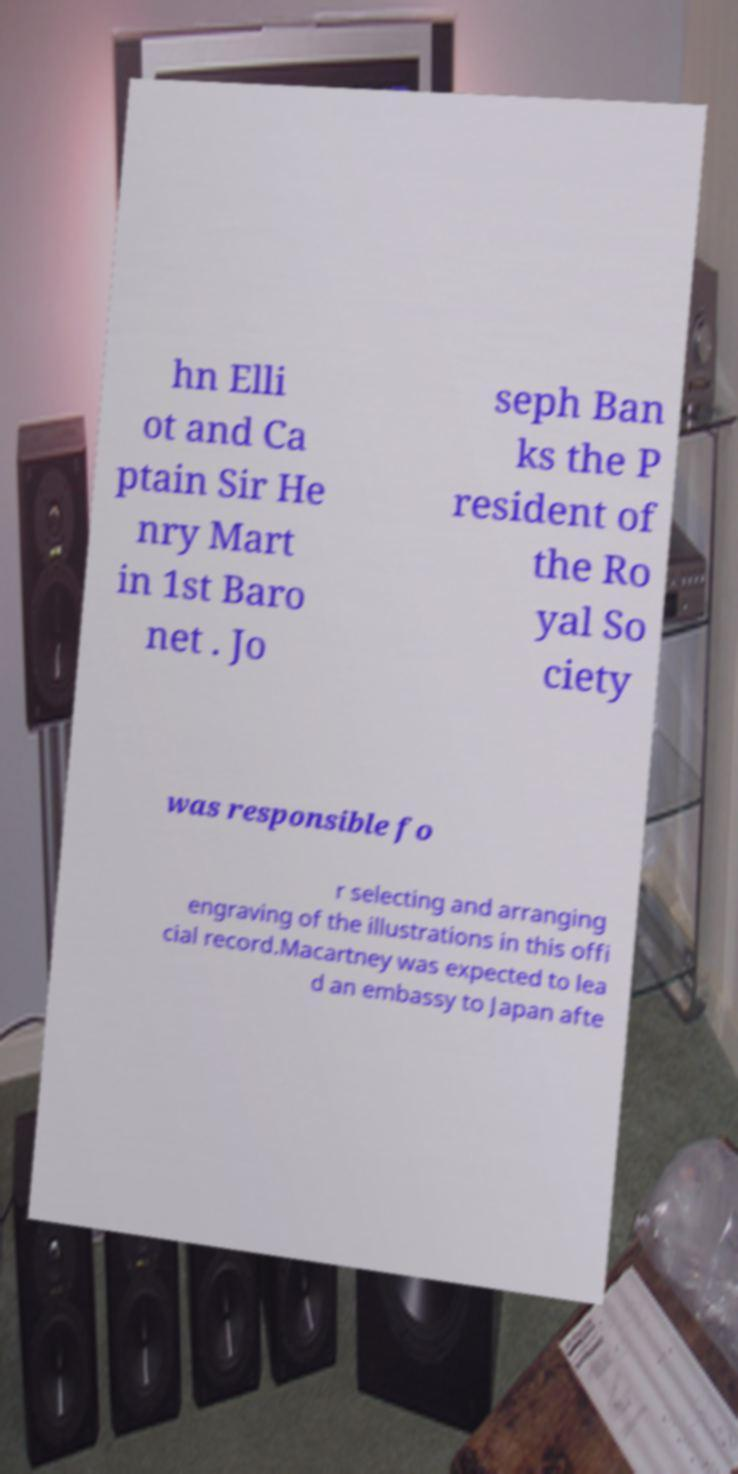I need the written content from this picture converted into text. Can you do that? hn Elli ot and Ca ptain Sir He nry Mart in 1st Baro net . Jo seph Ban ks the P resident of the Ro yal So ciety was responsible fo r selecting and arranging engraving of the illustrations in this offi cial record.Macartney was expected to lea d an embassy to Japan afte 